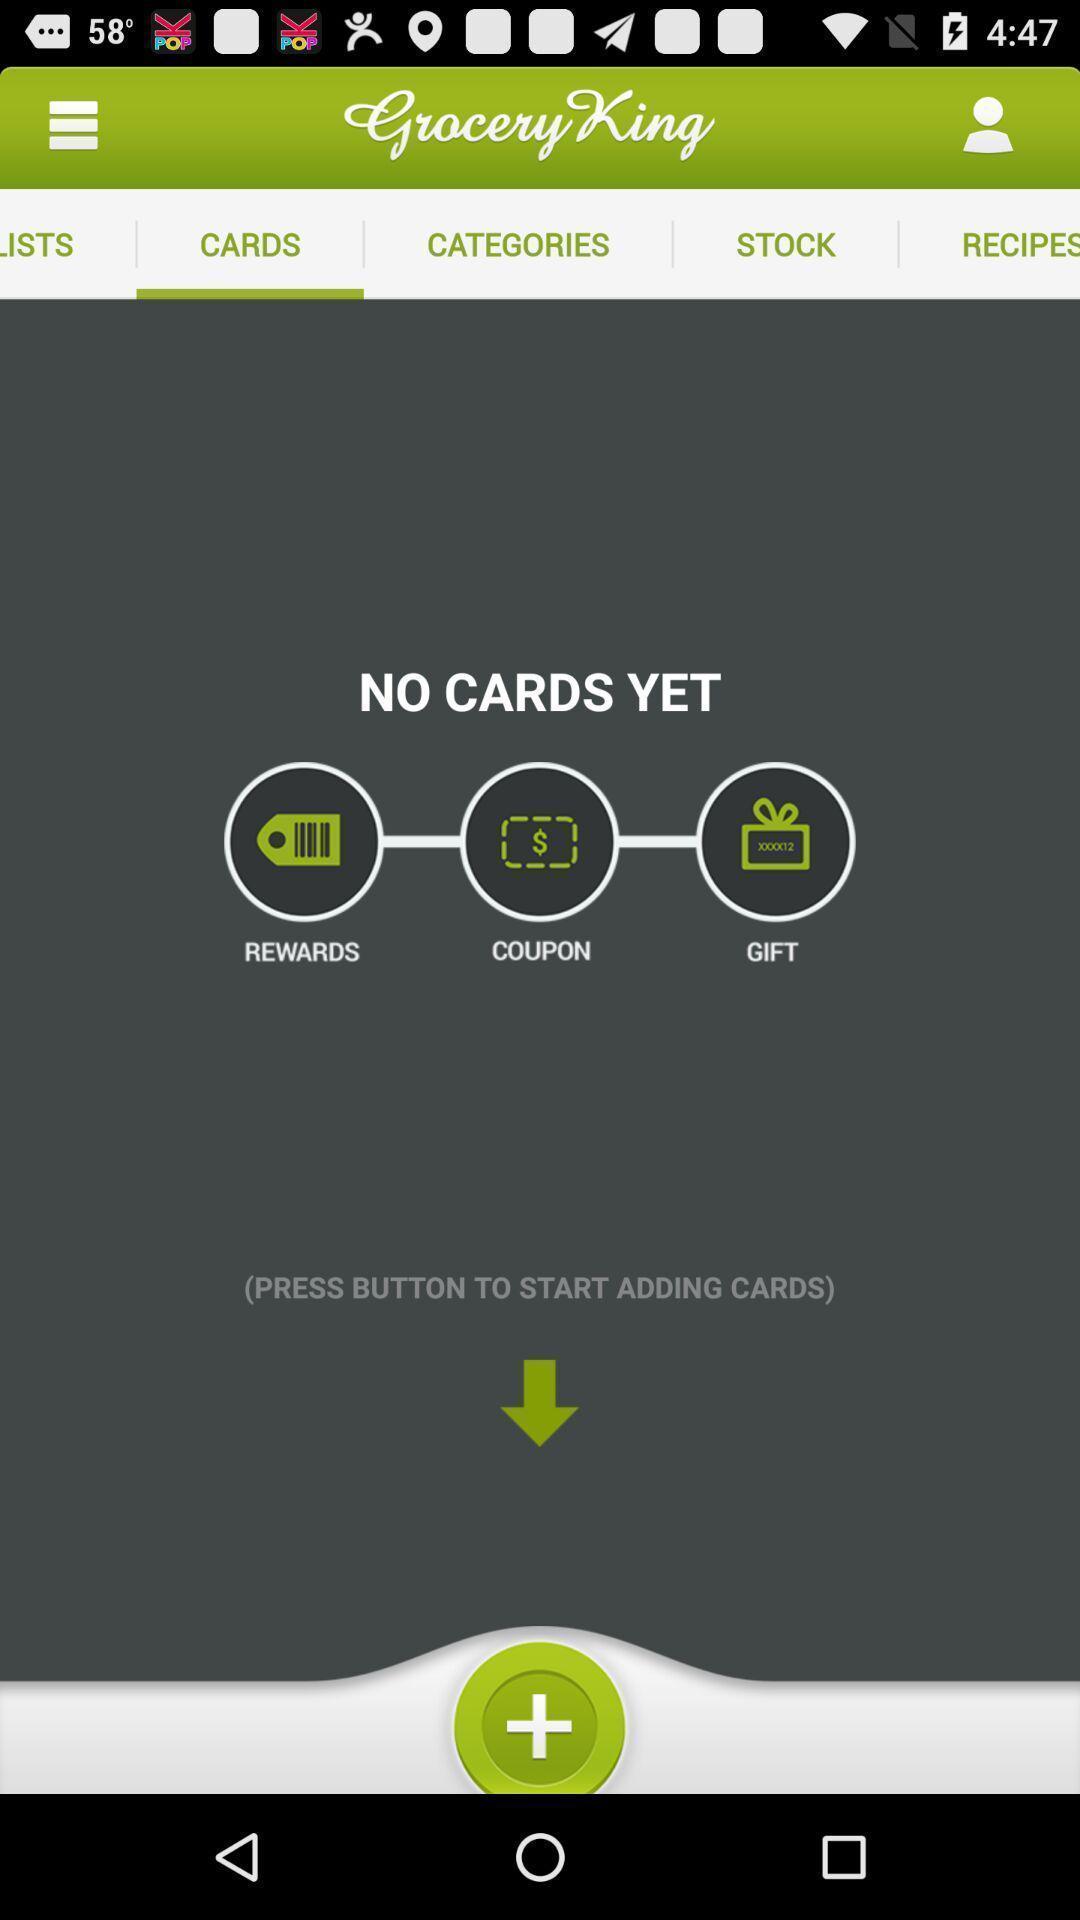Describe this image in words. Page showing different cards available. 